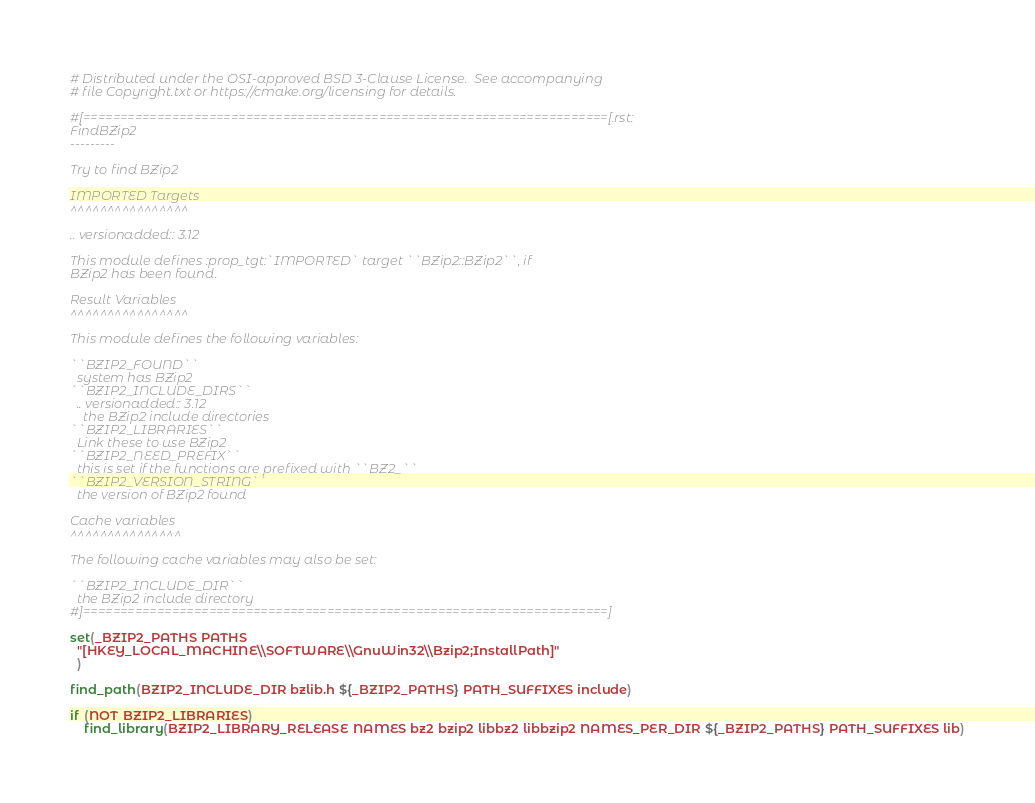Convert code to text. <code><loc_0><loc_0><loc_500><loc_500><_CMake_># Distributed under the OSI-approved BSD 3-Clause License.  See accompanying
# file Copyright.txt or https://cmake.org/licensing for details.

#[=======================================================================[.rst:
FindBZip2
---------

Try to find BZip2

IMPORTED Targets
^^^^^^^^^^^^^^^^

.. versionadded:: 3.12

This module defines :prop_tgt:`IMPORTED` target ``BZip2::BZip2``, if
BZip2 has been found.

Result Variables
^^^^^^^^^^^^^^^^

This module defines the following variables:

``BZIP2_FOUND``
  system has BZip2
``BZIP2_INCLUDE_DIRS``
  .. versionadded:: 3.12
    the BZip2 include directories
``BZIP2_LIBRARIES``
  Link these to use BZip2
``BZIP2_NEED_PREFIX``
  this is set if the functions are prefixed with ``BZ2_``
``BZIP2_VERSION_STRING``
  the version of BZip2 found

Cache variables
^^^^^^^^^^^^^^^

The following cache variables may also be set:

``BZIP2_INCLUDE_DIR``
  the BZip2 include directory
#]=======================================================================]

set(_BZIP2_PATHS PATHS
  "[HKEY_LOCAL_MACHINE\\SOFTWARE\\GnuWin32\\Bzip2;InstallPath]"
  )

find_path(BZIP2_INCLUDE_DIR bzlib.h ${_BZIP2_PATHS} PATH_SUFFIXES include)

if (NOT BZIP2_LIBRARIES)
    find_library(BZIP2_LIBRARY_RELEASE NAMES bz2 bzip2 libbz2 libbzip2 NAMES_PER_DIR ${_BZIP2_PATHS} PATH_SUFFIXES lib)</code> 